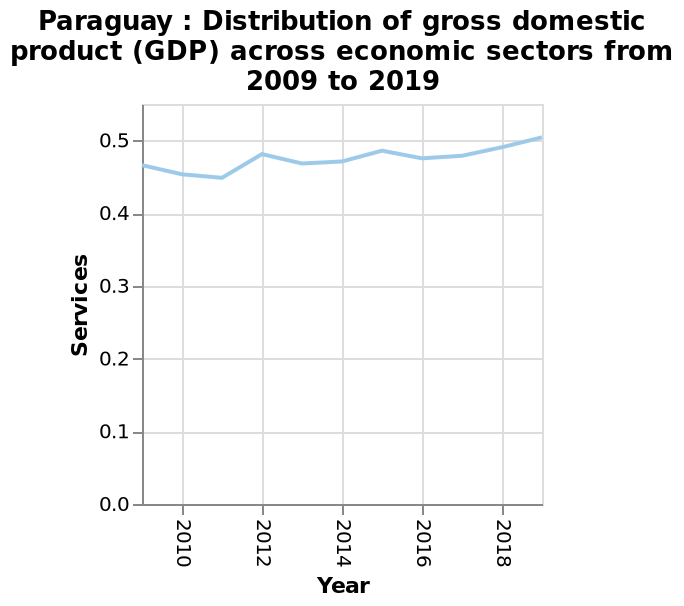<image>
What is measured along the y-axis in the line chart?  Services is measured along the y-axis in the line chart. 